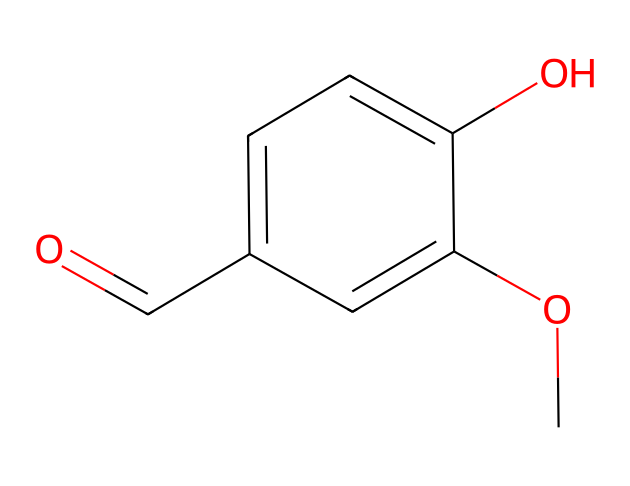What is the molecular formula of vanillin? To derive the molecular formula from the SMILES representation, count the number of each type of atom present. The chemical displays one carbonyl group (C=O) and twelve carbon atoms, plus an hydroxyl group (-OH) and methoxy group (-OCH3). This results in the molecular formula C8H8O3.
Answer: C8H8O3 How many carbon atoms are in vanillin? In the SMILES structure representation, one can count the total number of carbon (C) atoms present. There are eight carbon atoms visible in the provided structure.
Answer: 8 What functional group is present in vanillin? The structure shows a carbonyl group (C=O) bonded to an aromatic ring, characteristic of aldehydes. This indicates that vanillin contains an aldehyde functional group.
Answer: aldehyde How many oxygen atoms are in vanillin? The SMILES representation includes both a carbonyl (C=O) and two other oxygen atoms (as in the hydroxyl and methoxy groups). Counting these, vanillin has a total of three oxygen atoms.
Answer: 3 What is the primary functionality of vanillin? Vanillin acts as a flavoring compound primarily due to the aldehyde functional group, which contributes to its characteristic sweet flavor. This primary function is used in food and fragrance industries extensively.
Answer: flavoring What type of compound is vanillin classified as? Vanillin is classified as an aromatic aldehyde due to the presence of both the aromatic ring and the aldehyde functional group in its structure. This classification is significant to its chemical behavior and applications.
Answer: aromatic aldehyde Does vanillin have any hydroxyl groups? The presence of the hydroxyl functional group (-OH) can be confirmed by its visual representation in the structure. Thus, vanillin does contain a hydroxyl group, contributing to its properties.
Answer: yes 